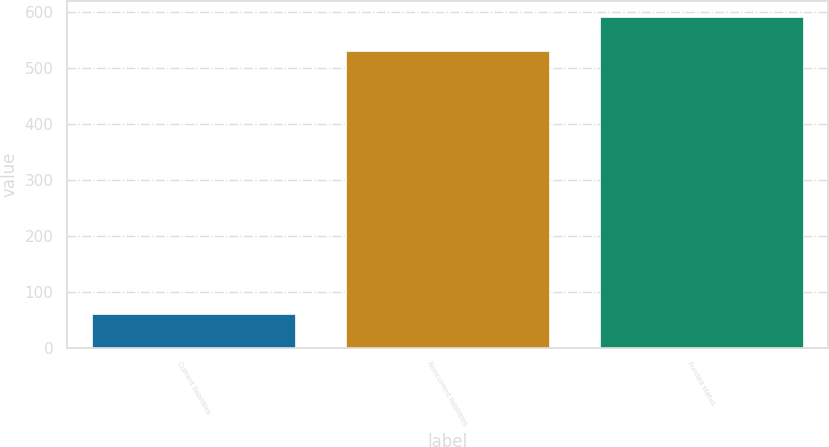Convert chart to OTSL. <chart><loc_0><loc_0><loc_500><loc_500><bar_chart><fcel>Current liabilities<fcel>Noncurrent liabilities<fcel>Funded status<nl><fcel>60<fcel>531<fcel>591<nl></chart> 